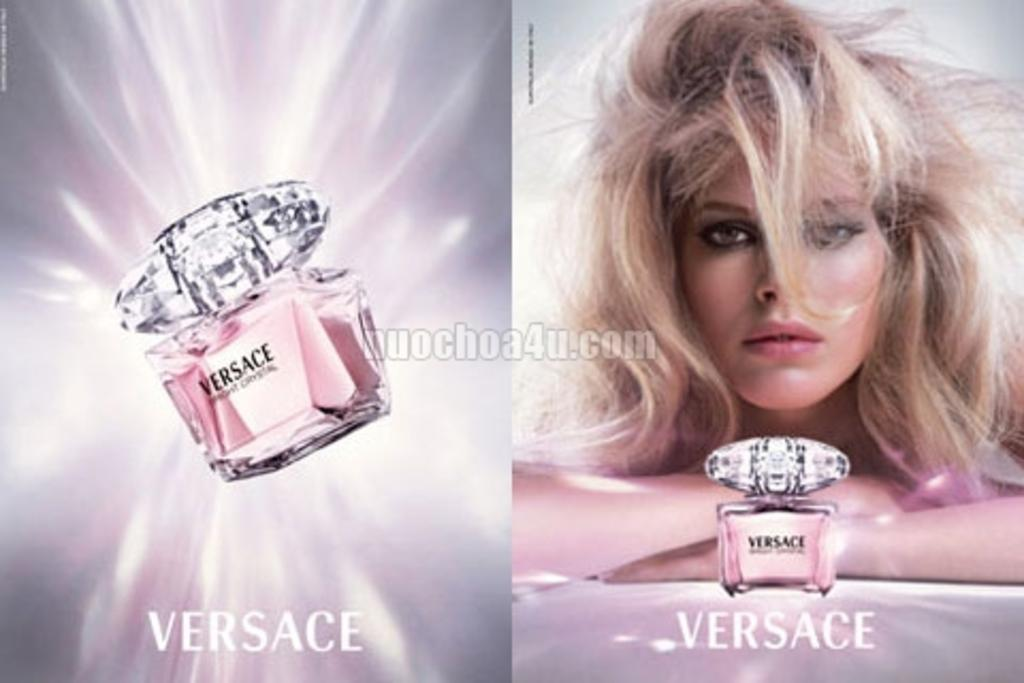<image>
Create a compact narrative representing the image presented. An advertisement for Versace perfume features a blonde woman with tousled hair. 